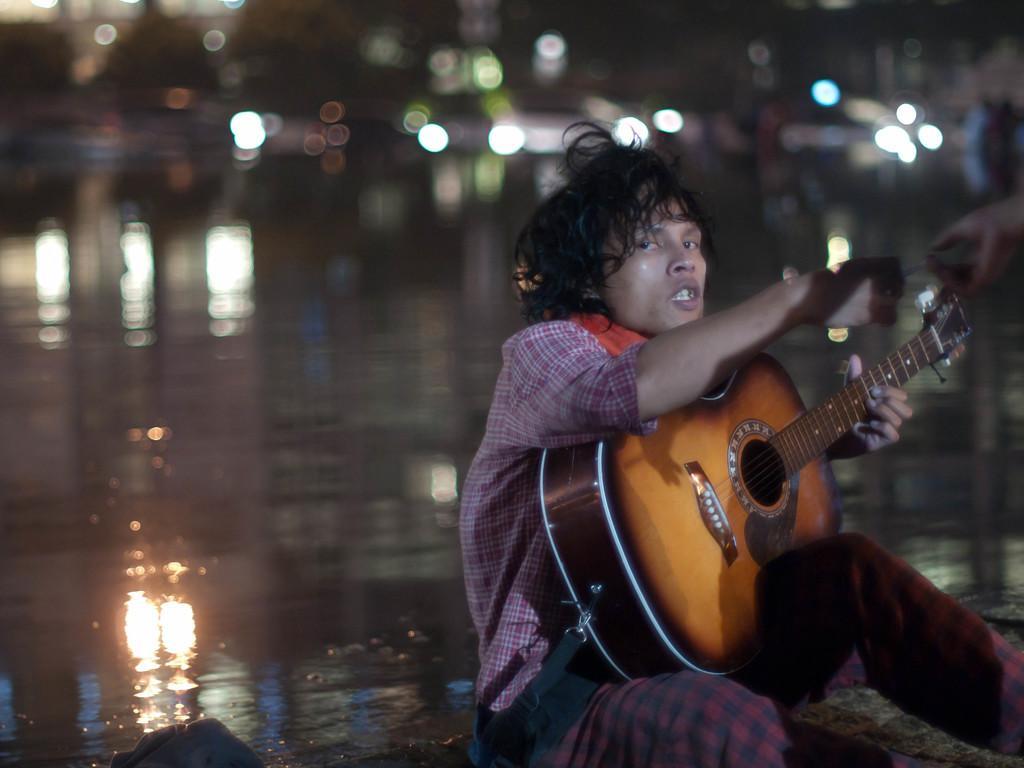In one or two sentences, can you explain what this image depicts? In this image I see a man who is holding a guitar and he is sitting on the path and I can also see another person's hand. In the background I see the water. 